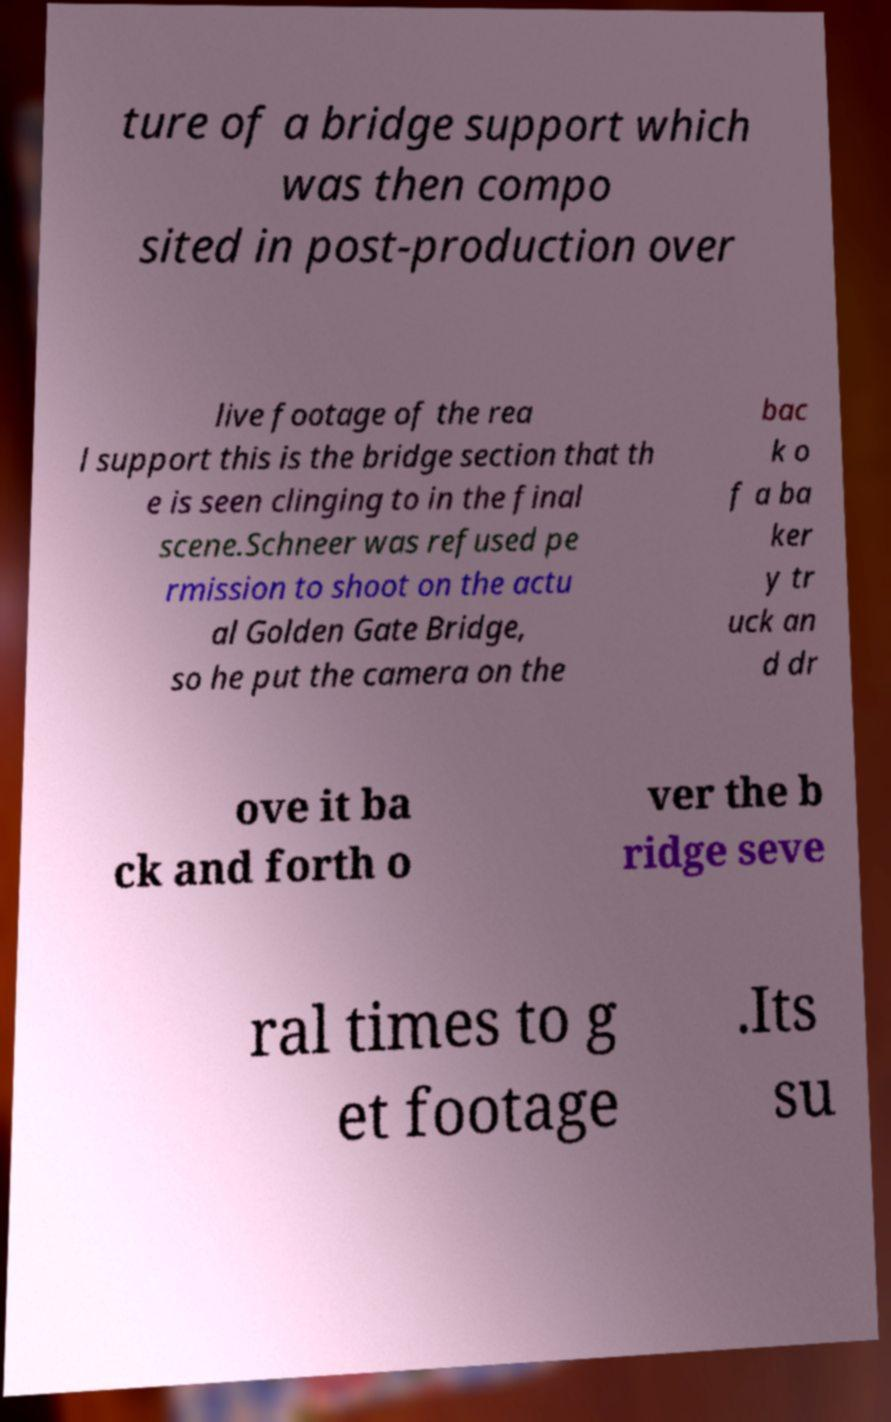There's text embedded in this image that I need extracted. Can you transcribe it verbatim? ture of a bridge support which was then compo sited in post-production over live footage of the rea l support this is the bridge section that th e is seen clinging to in the final scene.Schneer was refused pe rmission to shoot on the actu al Golden Gate Bridge, so he put the camera on the bac k o f a ba ker y tr uck an d dr ove it ba ck and forth o ver the b ridge seve ral times to g et footage .Its su 